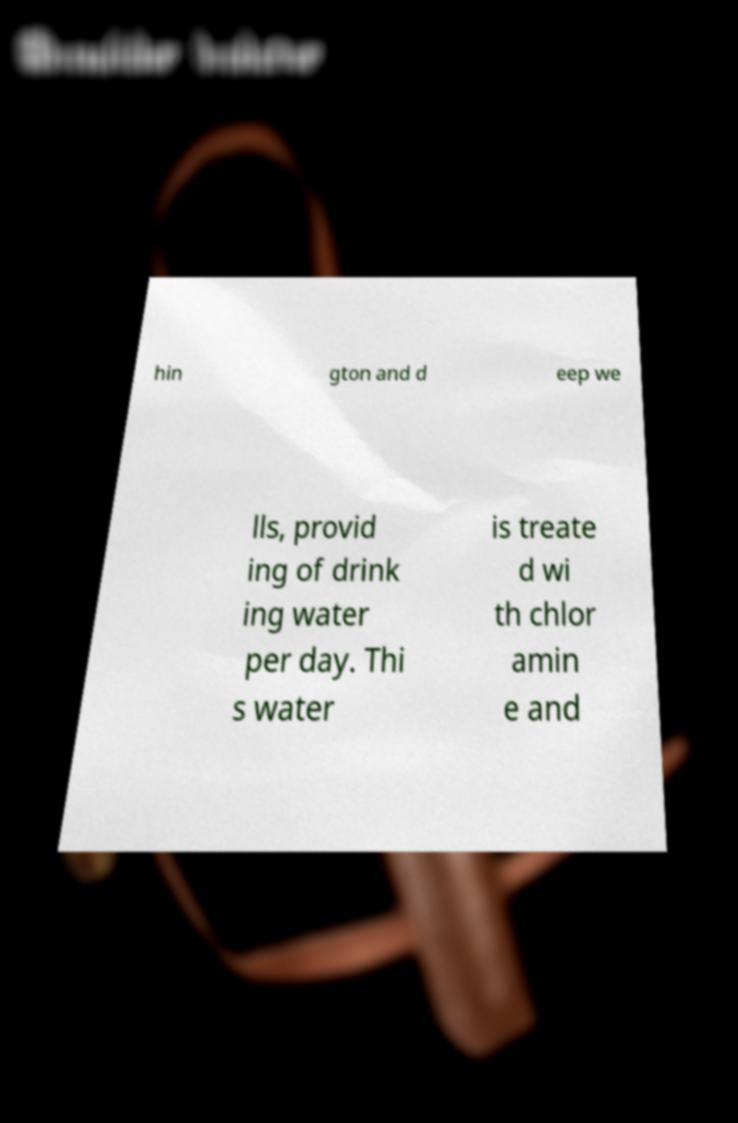Could you assist in decoding the text presented in this image and type it out clearly? hin gton and d eep we lls, provid ing of drink ing water per day. Thi s water is treate d wi th chlor amin e and 